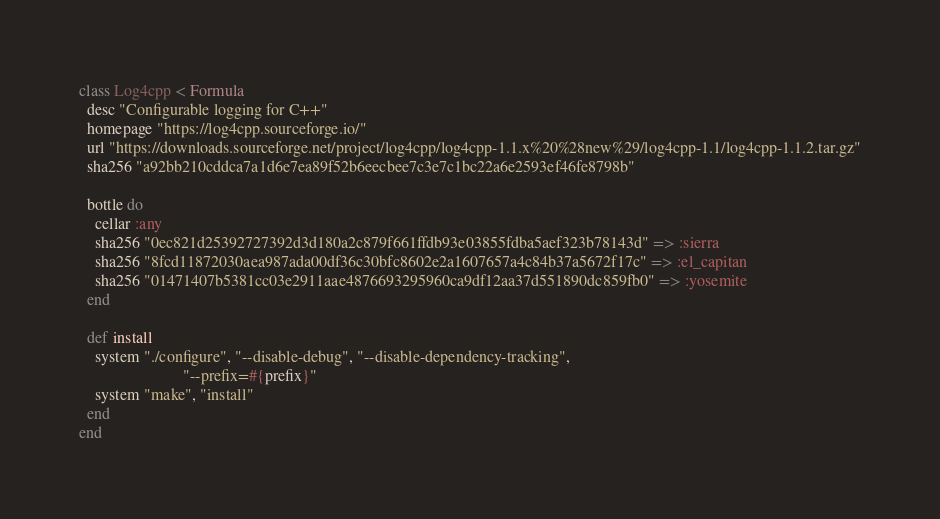<code> <loc_0><loc_0><loc_500><loc_500><_Ruby_>class Log4cpp < Formula
  desc "Configurable logging for C++"
  homepage "https://log4cpp.sourceforge.io/"
  url "https://downloads.sourceforge.net/project/log4cpp/log4cpp-1.1.x%20%28new%29/log4cpp-1.1/log4cpp-1.1.2.tar.gz"
  sha256 "a92bb210cddca7a1d6e7ea89f52b6eecbee7c3e7c1bc22a6e2593ef46fe8798b"

  bottle do
    cellar :any
    sha256 "0ec821d25392727392d3d180a2c879f661ffdb93e03855fdba5aef323b78143d" => :sierra
    sha256 "8fcd11872030aea987ada00df36c30bfc8602e2a1607657a4c84b37a5672f17c" => :el_capitan
    sha256 "01471407b5381cc03e2911aae4876693295960ca9df12aa37d551890dc859fb0" => :yosemite
  end

  def install
    system "./configure", "--disable-debug", "--disable-dependency-tracking",
                          "--prefix=#{prefix}"
    system "make", "install"
  end
end
</code> 